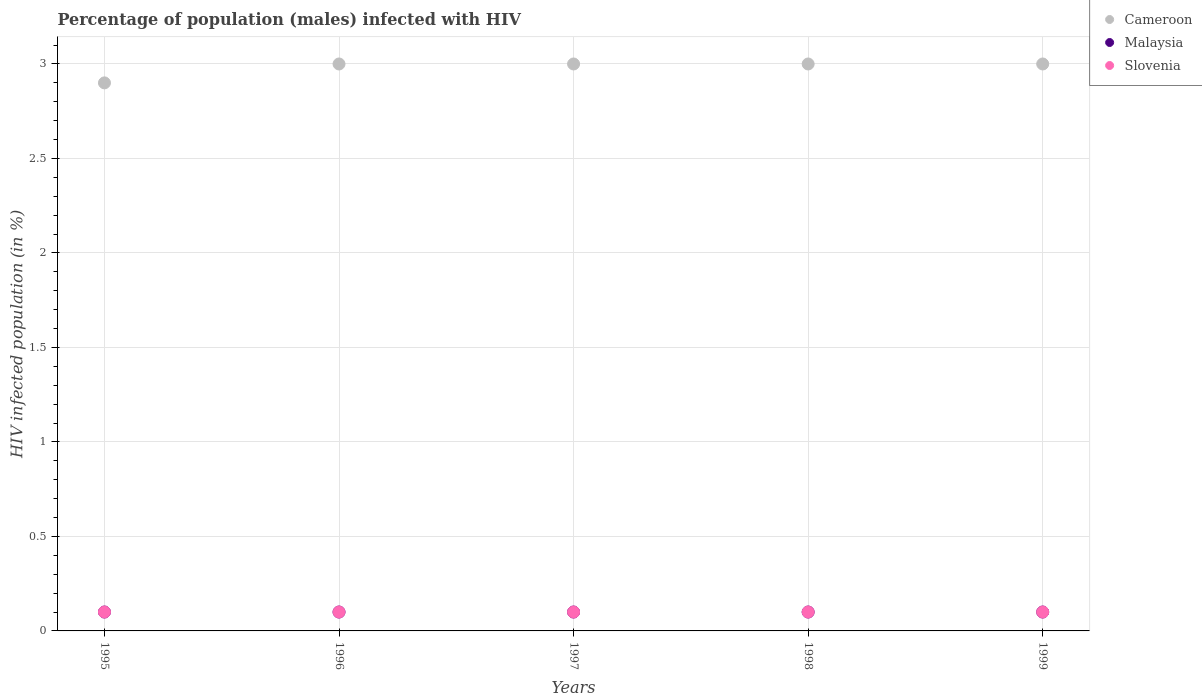How many different coloured dotlines are there?
Offer a terse response. 3. Across all years, what is the maximum percentage of HIV infected male population in Slovenia?
Offer a very short reply. 0.1. Across all years, what is the minimum percentage of HIV infected male population in Slovenia?
Ensure brevity in your answer.  0.1. In which year was the percentage of HIV infected male population in Malaysia minimum?
Offer a very short reply. 1995. What is the total percentage of HIV infected male population in Malaysia in the graph?
Your answer should be very brief. 0.5. What is the difference between the percentage of HIV infected male population in Malaysia in 1996 and that in 1998?
Your response must be concise. 0. What is the difference between the percentage of HIV infected male population in Malaysia in 1998 and the percentage of HIV infected male population in Cameroon in 1999?
Provide a short and direct response. -2.9. In the year 1997, what is the difference between the percentage of HIV infected male population in Slovenia and percentage of HIV infected male population in Cameroon?
Your response must be concise. -2.9. In how many years, is the percentage of HIV infected male population in Malaysia greater than 2.9 %?
Offer a very short reply. 0. What is the ratio of the percentage of HIV infected male population in Cameroon in 1997 to that in 1999?
Make the answer very short. 1. Is the percentage of HIV infected male population in Slovenia in 1996 less than that in 1997?
Ensure brevity in your answer.  No. Is the difference between the percentage of HIV infected male population in Slovenia in 1997 and 1998 greater than the difference between the percentage of HIV infected male population in Cameroon in 1997 and 1998?
Make the answer very short. No. In how many years, is the percentage of HIV infected male population in Malaysia greater than the average percentage of HIV infected male population in Malaysia taken over all years?
Make the answer very short. 0. Is the sum of the percentage of HIV infected male population in Cameroon in 1998 and 1999 greater than the maximum percentage of HIV infected male population in Slovenia across all years?
Offer a very short reply. Yes. Is it the case that in every year, the sum of the percentage of HIV infected male population in Slovenia and percentage of HIV infected male population in Malaysia  is greater than the percentage of HIV infected male population in Cameroon?
Ensure brevity in your answer.  No. Does the percentage of HIV infected male population in Slovenia monotonically increase over the years?
Offer a very short reply. No. Is the percentage of HIV infected male population in Malaysia strictly greater than the percentage of HIV infected male population in Slovenia over the years?
Your answer should be compact. No. How many dotlines are there?
Offer a terse response. 3. How many years are there in the graph?
Your response must be concise. 5. What is the difference between two consecutive major ticks on the Y-axis?
Your answer should be very brief. 0.5. What is the title of the graph?
Keep it short and to the point. Percentage of population (males) infected with HIV. Does "OECD members" appear as one of the legend labels in the graph?
Ensure brevity in your answer.  No. What is the label or title of the X-axis?
Provide a short and direct response. Years. What is the label or title of the Y-axis?
Make the answer very short. HIV infected population (in %). What is the HIV infected population (in %) of Cameroon in 1995?
Provide a succinct answer. 2.9. What is the HIV infected population (in %) of Slovenia in 1995?
Your answer should be very brief. 0.1. What is the HIV infected population (in %) of Cameroon in 1996?
Make the answer very short. 3. What is the HIV infected population (in %) in Malaysia in 1996?
Provide a succinct answer. 0.1. What is the HIV infected population (in %) of Malaysia in 1998?
Offer a terse response. 0.1. What is the HIV infected population (in %) of Malaysia in 1999?
Ensure brevity in your answer.  0.1. Across all years, what is the maximum HIV infected population (in %) in Cameroon?
Your response must be concise. 3. Across all years, what is the maximum HIV infected population (in %) in Slovenia?
Give a very brief answer. 0.1. Across all years, what is the minimum HIV infected population (in %) of Cameroon?
Your answer should be very brief. 2.9. Across all years, what is the minimum HIV infected population (in %) in Malaysia?
Your answer should be very brief. 0.1. What is the total HIV infected population (in %) in Cameroon in the graph?
Provide a short and direct response. 14.9. What is the total HIV infected population (in %) in Slovenia in the graph?
Your answer should be very brief. 0.5. What is the difference between the HIV infected population (in %) of Malaysia in 1995 and that in 1996?
Provide a short and direct response. 0. What is the difference between the HIV infected population (in %) of Cameroon in 1995 and that in 1997?
Give a very brief answer. -0.1. What is the difference between the HIV infected population (in %) in Malaysia in 1995 and that in 1997?
Your answer should be compact. 0. What is the difference between the HIV infected population (in %) in Cameroon in 1995 and that in 1998?
Provide a short and direct response. -0.1. What is the difference between the HIV infected population (in %) of Malaysia in 1995 and that in 1998?
Provide a short and direct response. 0. What is the difference between the HIV infected population (in %) in Malaysia in 1995 and that in 1999?
Ensure brevity in your answer.  0. What is the difference between the HIV infected population (in %) in Slovenia in 1995 and that in 1999?
Provide a succinct answer. 0. What is the difference between the HIV infected population (in %) in Malaysia in 1996 and that in 1997?
Provide a short and direct response. 0. What is the difference between the HIV infected population (in %) in Cameroon in 1996 and that in 1998?
Give a very brief answer. 0. What is the difference between the HIV infected population (in %) of Slovenia in 1996 and that in 1998?
Ensure brevity in your answer.  0. What is the difference between the HIV infected population (in %) in Cameroon in 1996 and that in 1999?
Make the answer very short. 0. What is the difference between the HIV infected population (in %) in Malaysia in 1996 and that in 1999?
Give a very brief answer. 0. What is the difference between the HIV infected population (in %) of Slovenia in 1996 and that in 1999?
Your answer should be very brief. 0. What is the difference between the HIV infected population (in %) of Cameroon in 1997 and that in 1999?
Give a very brief answer. 0. What is the difference between the HIV infected population (in %) in Malaysia in 1997 and that in 1999?
Keep it short and to the point. 0. What is the difference between the HIV infected population (in %) of Slovenia in 1997 and that in 1999?
Provide a succinct answer. 0. What is the difference between the HIV infected population (in %) of Malaysia in 1998 and that in 1999?
Ensure brevity in your answer.  0. What is the difference between the HIV infected population (in %) of Slovenia in 1998 and that in 1999?
Give a very brief answer. 0. What is the difference between the HIV infected population (in %) of Cameroon in 1995 and the HIV infected population (in %) of Malaysia in 1997?
Provide a succinct answer. 2.8. What is the difference between the HIV infected population (in %) of Malaysia in 1995 and the HIV infected population (in %) of Slovenia in 1997?
Keep it short and to the point. 0. What is the difference between the HIV infected population (in %) in Malaysia in 1995 and the HIV infected population (in %) in Slovenia in 1998?
Give a very brief answer. 0. What is the difference between the HIV infected population (in %) of Cameroon in 1995 and the HIV infected population (in %) of Malaysia in 1999?
Offer a terse response. 2.8. What is the difference between the HIV infected population (in %) of Malaysia in 1996 and the HIV infected population (in %) of Slovenia in 1997?
Ensure brevity in your answer.  0. What is the difference between the HIV infected population (in %) of Cameroon in 1996 and the HIV infected population (in %) of Slovenia in 1998?
Your answer should be compact. 2.9. What is the difference between the HIV infected population (in %) in Malaysia in 1996 and the HIV infected population (in %) in Slovenia in 1998?
Make the answer very short. 0. What is the difference between the HIV infected population (in %) in Cameroon in 1996 and the HIV infected population (in %) in Malaysia in 1999?
Your response must be concise. 2.9. What is the difference between the HIV infected population (in %) in Malaysia in 1996 and the HIV infected population (in %) in Slovenia in 1999?
Provide a succinct answer. 0. What is the difference between the HIV infected population (in %) in Cameroon in 1997 and the HIV infected population (in %) in Malaysia in 1998?
Provide a short and direct response. 2.9. What is the difference between the HIV infected population (in %) of Cameroon in 1997 and the HIV infected population (in %) of Slovenia in 1998?
Provide a short and direct response. 2.9. What is the difference between the HIV infected population (in %) of Malaysia in 1998 and the HIV infected population (in %) of Slovenia in 1999?
Provide a succinct answer. 0. What is the average HIV infected population (in %) of Cameroon per year?
Make the answer very short. 2.98. What is the average HIV infected population (in %) in Malaysia per year?
Your answer should be very brief. 0.1. In the year 1995, what is the difference between the HIV infected population (in %) of Cameroon and HIV infected population (in %) of Slovenia?
Ensure brevity in your answer.  2.8. In the year 1995, what is the difference between the HIV infected population (in %) of Malaysia and HIV infected population (in %) of Slovenia?
Provide a succinct answer. 0. In the year 1996, what is the difference between the HIV infected population (in %) in Cameroon and HIV infected population (in %) in Malaysia?
Offer a very short reply. 2.9. In the year 1997, what is the difference between the HIV infected population (in %) in Cameroon and HIV infected population (in %) in Malaysia?
Make the answer very short. 2.9. In the year 1997, what is the difference between the HIV infected population (in %) of Cameroon and HIV infected population (in %) of Slovenia?
Make the answer very short. 2.9. In the year 1997, what is the difference between the HIV infected population (in %) of Malaysia and HIV infected population (in %) of Slovenia?
Your answer should be compact. 0. In the year 1998, what is the difference between the HIV infected population (in %) of Cameroon and HIV infected population (in %) of Slovenia?
Provide a short and direct response. 2.9. In the year 1999, what is the difference between the HIV infected population (in %) of Cameroon and HIV infected population (in %) of Slovenia?
Offer a terse response. 2.9. In the year 1999, what is the difference between the HIV infected population (in %) of Malaysia and HIV infected population (in %) of Slovenia?
Make the answer very short. 0. What is the ratio of the HIV infected population (in %) of Cameroon in 1995 to that in 1996?
Keep it short and to the point. 0.97. What is the ratio of the HIV infected population (in %) of Slovenia in 1995 to that in 1996?
Your answer should be very brief. 1. What is the ratio of the HIV infected population (in %) in Cameroon in 1995 to that in 1997?
Make the answer very short. 0.97. What is the ratio of the HIV infected population (in %) in Cameroon in 1995 to that in 1998?
Your answer should be compact. 0.97. What is the ratio of the HIV infected population (in %) of Malaysia in 1995 to that in 1998?
Keep it short and to the point. 1. What is the ratio of the HIV infected population (in %) in Slovenia in 1995 to that in 1998?
Give a very brief answer. 1. What is the ratio of the HIV infected population (in %) of Cameroon in 1995 to that in 1999?
Your answer should be compact. 0.97. What is the ratio of the HIV infected population (in %) in Slovenia in 1995 to that in 1999?
Provide a succinct answer. 1. What is the ratio of the HIV infected population (in %) in Cameroon in 1996 to that in 1997?
Your answer should be very brief. 1. What is the ratio of the HIV infected population (in %) of Malaysia in 1996 to that in 1997?
Your answer should be compact. 1. What is the ratio of the HIV infected population (in %) in Cameroon in 1996 to that in 1998?
Offer a very short reply. 1. What is the ratio of the HIV infected population (in %) in Malaysia in 1996 to that in 1998?
Provide a succinct answer. 1. What is the ratio of the HIV infected population (in %) of Slovenia in 1996 to that in 1999?
Ensure brevity in your answer.  1. What is the ratio of the HIV infected population (in %) in Slovenia in 1997 to that in 1998?
Provide a short and direct response. 1. What is the difference between the highest and the second highest HIV infected population (in %) of Malaysia?
Keep it short and to the point. 0. What is the difference between the highest and the lowest HIV infected population (in %) of Slovenia?
Keep it short and to the point. 0. 